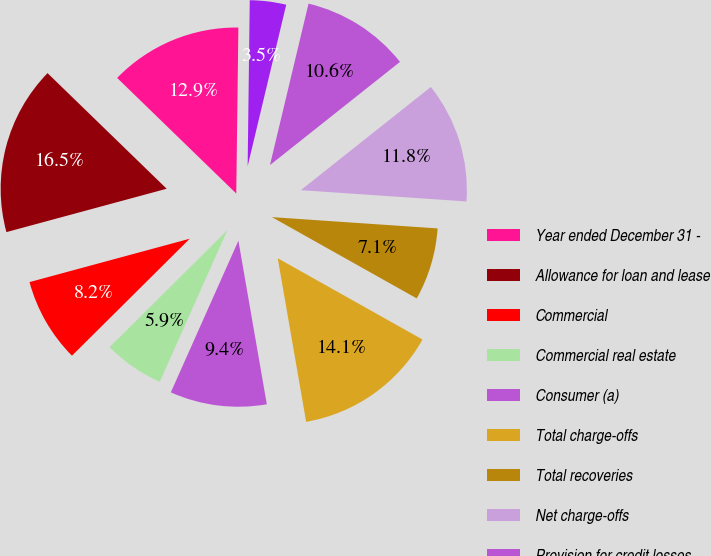Convert chart. <chart><loc_0><loc_0><loc_500><loc_500><pie_chart><fcel>Year ended December 31 -<fcel>Allowance for loan and lease<fcel>Commercial<fcel>Commercial real estate<fcel>Consumer (a)<fcel>Total charge-offs<fcel>Total recoveries<fcel>Net charge-offs<fcel>Provision for credit losses<fcel>Net change in allowance for<nl><fcel>12.94%<fcel>16.47%<fcel>8.24%<fcel>5.88%<fcel>9.41%<fcel>14.12%<fcel>7.06%<fcel>11.76%<fcel>10.59%<fcel>3.53%<nl></chart> 